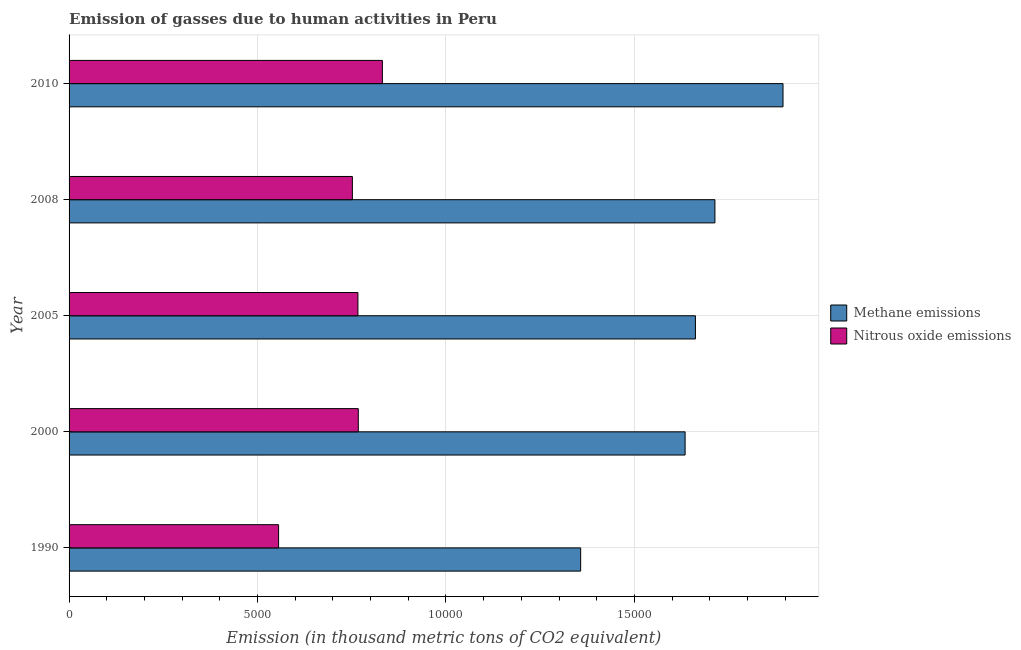How many different coloured bars are there?
Keep it short and to the point. 2. How many groups of bars are there?
Keep it short and to the point. 5. Are the number of bars on each tick of the Y-axis equal?
Give a very brief answer. Yes. How many bars are there on the 5th tick from the top?
Keep it short and to the point. 2. How many bars are there on the 1st tick from the bottom?
Keep it short and to the point. 2. What is the amount of nitrous oxide emissions in 1990?
Keep it short and to the point. 5559.3. Across all years, what is the maximum amount of methane emissions?
Your answer should be very brief. 1.89e+04. Across all years, what is the minimum amount of nitrous oxide emissions?
Your response must be concise. 5559.3. In which year was the amount of nitrous oxide emissions maximum?
Ensure brevity in your answer.  2010. What is the total amount of methane emissions in the graph?
Provide a short and direct response. 8.26e+04. What is the difference between the amount of methane emissions in 1990 and that in 2008?
Provide a short and direct response. -3562.7. What is the difference between the amount of methane emissions in 2000 and the amount of nitrous oxide emissions in 1990?
Provide a succinct answer. 1.08e+04. What is the average amount of nitrous oxide emissions per year?
Provide a succinct answer. 7345.44. In the year 2000, what is the difference between the amount of nitrous oxide emissions and amount of methane emissions?
Give a very brief answer. -8671.2. What is the difference between the highest and the second highest amount of nitrous oxide emissions?
Provide a succinct answer. 639.1. What is the difference between the highest and the lowest amount of nitrous oxide emissions?
Provide a succinct answer. 2753.7. What does the 1st bar from the top in 2000 represents?
Ensure brevity in your answer.  Nitrous oxide emissions. What does the 2nd bar from the bottom in 2010 represents?
Keep it short and to the point. Nitrous oxide emissions. How many bars are there?
Keep it short and to the point. 10. Are all the bars in the graph horizontal?
Offer a very short reply. Yes. How many years are there in the graph?
Provide a short and direct response. 5. Does the graph contain any zero values?
Your answer should be very brief. No. Does the graph contain grids?
Your response must be concise. Yes. How many legend labels are there?
Offer a very short reply. 2. How are the legend labels stacked?
Provide a succinct answer. Vertical. What is the title of the graph?
Give a very brief answer. Emission of gasses due to human activities in Peru. What is the label or title of the X-axis?
Make the answer very short. Emission (in thousand metric tons of CO2 equivalent). What is the label or title of the Y-axis?
Offer a very short reply. Year. What is the Emission (in thousand metric tons of CO2 equivalent) in Methane emissions in 1990?
Your answer should be compact. 1.36e+04. What is the Emission (in thousand metric tons of CO2 equivalent) of Nitrous oxide emissions in 1990?
Keep it short and to the point. 5559.3. What is the Emission (in thousand metric tons of CO2 equivalent) in Methane emissions in 2000?
Give a very brief answer. 1.63e+04. What is the Emission (in thousand metric tons of CO2 equivalent) in Nitrous oxide emissions in 2000?
Your answer should be very brief. 7673.9. What is the Emission (in thousand metric tons of CO2 equivalent) of Methane emissions in 2005?
Ensure brevity in your answer.  1.66e+04. What is the Emission (in thousand metric tons of CO2 equivalent) in Nitrous oxide emissions in 2005?
Offer a terse response. 7664.2. What is the Emission (in thousand metric tons of CO2 equivalent) in Methane emissions in 2008?
Keep it short and to the point. 1.71e+04. What is the Emission (in thousand metric tons of CO2 equivalent) in Nitrous oxide emissions in 2008?
Offer a terse response. 7516.8. What is the Emission (in thousand metric tons of CO2 equivalent) of Methane emissions in 2010?
Your answer should be very brief. 1.89e+04. What is the Emission (in thousand metric tons of CO2 equivalent) in Nitrous oxide emissions in 2010?
Ensure brevity in your answer.  8313. Across all years, what is the maximum Emission (in thousand metric tons of CO2 equivalent) in Methane emissions?
Ensure brevity in your answer.  1.89e+04. Across all years, what is the maximum Emission (in thousand metric tons of CO2 equivalent) in Nitrous oxide emissions?
Offer a terse response. 8313. Across all years, what is the minimum Emission (in thousand metric tons of CO2 equivalent) in Methane emissions?
Your answer should be compact. 1.36e+04. Across all years, what is the minimum Emission (in thousand metric tons of CO2 equivalent) in Nitrous oxide emissions?
Offer a terse response. 5559.3. What is the total Emission (in thousand metric tons of CO2 equivalent) of Methane emissions in the graph?
Your answer should be very brief. 8.26e+04. What is the total Emission (in thousand metric tons of CO2 equivalent) of Nitrous oxide emissions in the graph?
Offer a terse response. 3.67e+04. What is the difference between the Emission (in thousand metric tons of CO2 equivalent) in Methane emissions in 1990 and that in 2000?
Offer a very short reply. -2771.4. What is the difference between the Emission (in thousand metric tons of CO2 equivalent) of Nitrous oxide emissions in 1990 and that in 2000?
Keep it short and to the point. -2114.6. What is the difference between the Emission (in thousand metric tons of CO2 equivalent) of Methane emissions in 1990 and that in 2005?
Provide a short and direct response. -3045.3. What is the difference between the Emission (in thousand metric tons of CO2 equivalent) in Nitrous oxide emissions in 1990 and that in 2005?
Provide a succinct answer. -2104.9. What is the difference between the Emission (in thousand metric tons of CO2 equivalent) of Methane emissions in 1990 and that in 2008?
Keep it short and to the point. -3562.7. What is the difference between the Emission (in thousand metric tons of CO2 equivalent) of Nitrous oxide emissions in 1990 and that in 2008?
Keep it short and to the point. -1957.5. What is the difference between the Emission (in thousand metric tons of CO2 equivalent) of Methane emissions in 1990 and that in 2010?
Provide a short and direct response. -5369.2. What is the difference between the Emission (in thousand metric tons of CO2 equivalent) of Nitrous oxide emissions in 1990 and that in 2010?
Provide a short and direct response. -2753.7. What is the difference between the Emission (in thousand metric tons of CO2 equivalent) of Methane emissions in 2000 and that in 2005?
Your answer should be compact. -273.9. What is the difference between the Emission (in thousand metric tons of CO2 equivalent) of Methane emissions in 2000 and that in 2008?
Offer a terse response. -791.3. What is the difference between the Emission (in thousand metric tons of CO2 equivalent) in Nitrous oxide emissions in 2000 and that in 2008?
Offer a very short reply. 157.1. What is the difference between the Emission (in thousand metric tons of CO2 equivalent) in Methane emissions in 2000 and that in 2010?
Make the answer very short. -2597.8. What is the difference between the Emission (in thousand metric tons of CO2 equivalent) of Nitrous oxide emissions in 2000 and that in 2010?
Keep it short and to the point. -639.1. What is the difference between the Emission (in thousand metric tons of CO2 equivalent) of Methane emissions in 2005 and that in 2008?
Keep it short and to the point. -517.4. What is the difference between the Emission (in thousand metric tons of CO2 equivalent) in Nitrous oxide emissions in 2005 and that in 2008?
Offer a terse response. 147.4. What is the difference between the Emission (in thousand metric tons of CO2 equivalent) of Methane emissions in 2005 and that in 2010?
Ensure brevity in your answer.  -2323.9. What is the difference between the Emission (in thousand metric tons of CO2 equivalent) of Nitrous oxide emissions in 2005 and that in 2010?
Give a very brief answer. -648.8. What is the difference between the Emission (in thousand metric tons of CO2 equivalent) of Methane emissions in 2008 and that in 2010?
Keep it short and to the point. -1806.5. What is the difference between the Emission (in thousand metric tons of CO2 equivalent) in Nitrous oxide emissions in 2008 and that in 2010?
Provide a short and direct response. -796.2. What is the difference between the Emission (in thousand metric tons of CO2 equivalent) in Methane emissions in 1990 and the Emission (in thousand metric tons of CO2 equivalent) in Nitrous oxide emissions in 2000?
Keep it short and to the point. 5899.8. What is the difference between the Emission (in thousand metric tons of CO2 equivalent) in Methane emissions in 1990 and the Emission (in thousand metric tons of CO2 equivalent) in Nitrous oxide emissions in 2005?
Your response must be concise. 5909.5. What is the difference between the Emission (in thousand metric tons of CO2 equivalent) of Methane emissions in 1990 and the Emission (in thousand metric tons of CO2 equivalent) of Nitrous oxide emissions in 2008?
Offer a terse response. 6056.9. What is the difference between the Emission (in thousand metric tons of CO2 equivalent) in Methane emissions in 1990 and the Emission (in thousand metric tons of CO2 equivalent) in Nitrous oxide emissions in 2010?
Give a very brief answer. 5260.7. What is the difference between the Emission (in thousand metric tons of CO2 equivalent) of Methane emissions in 2000 and the Emission (in thousand metric tons of CO2 equivalent) of Nitrous oxide emissions in 2005?
Provide a short and direct response. 8680.9. What is the difference between the Emission (in thousand metric tons of CO2 equivalent) in Methane emissions in 2000 and the Emission (in thousand metric tons of CO2 equivalent) in Nitrous oxide emissions in 2008?
Offer a very short reply. 8828.3. What is the difference between the Emission (in thousand metric tons of CO2 equivalent) in Methane emissions in 2000 and the Emission (in thousand metric tons of CO2 equivalent) in Nitrous oxide emissions in 2010?
Give a very brief answer. 8032.1. What is the difference between the Emission (in thousand metric tons of CO2 equivalent) of Methane emissions in 2005 and the Emission (in thousand metric tons of CO2 equivalent) of Nitrous oxide emissions in 2008?
Make the answer very short. 9102.2. What is the difference between the Emission (in thousand metric tons of CO2 equivalent) of Methane emissions in 2005 and the Emission (in thousand metric tons of CO2 equivalent) of Nitrous oxide emissions in 2010?
Give a very brief answer. 8306. What is the difference between the Emission (in thousand metric tons of CO2 equivalent) of Methane emissions in 2008 and the Emission (in thousand metric tons of CO2 equivalent) of Nitrous oxide emissions in 2010?
Ensure brevity in your answer.  8823.4. What is the average Emission (in thousand metric tons of CO2 equivalent) in Methane emissions per year?
Keep it short and to the point. 1.65e+04. What is the average Emission (in thousand metric tons of CO2 equivalent) in Nitrous oxide emissions per year?
Offer a terse response. 7345.44. In the year 1990, what is the difference between the Emission (in thousand metric tons of CO2 equivalent) in Methane emissions and Emission (in thousand metric tons of CO2 equivalent) in Nitrous oxide emissions?
Your answer should be compact. 8014.4. In the year 2000, what is the difference between the Emission (in thousand metric tons of CO2 equivalent) of Methane emissions and Emission (in thousand metric tons of CO2 equivalent) of Nitrous oxide emissions?
Offer a very short reply. 8671.2. In the year 2005, what is the difference between the Emission (in thousand metric tons of CO2 equivalent) of Methane emissions and Emission (in thousand metric tons of CO2 equivalent) of Nitrous oxide emissions?
Ensure brevity in your answer.  8954.8. In the year 2008, what is the difference between the Emission (in thousand metric tons of CO2 equivalent) of Methane emissions and Emission (in thousand metric tons of CO2 equivalent) of Nitrous oxide emissions?
Your answer should be compact. 9619.6. In the year 2010, what is the difference between the Emission (in thousand metric tons of CO2 equivalent) of Methane emissions and Emission (in thousand metric tons of CO2 equivalent) of Nitrous oxide emissions?
Provide a short and direct response. 1.06e+04. What is the ratio of the Emission (in thousand metric tons of CO2 equivalent) of Methane emissions in 1990 to that in 2000?
Your answer should be compact. 0.83. What is the ratio of the Emission (in thousand metric tons of CO2 equivalent) in Nitrous oxide emissions in 1990 to that in 2000?
Give a very brief answer. 0.72. What is the ratio of the Emission (in thousand metric tons of CO2 equivalent) in Methane emissions in 1990 to that in 2005?
Offer a terse response. 0.82. What is the ratio of the Emission (in thousand metric tons of CO2 equivalent) in Nitrous oxide emissions in 1990 to that in 2005?
Provide a short and direct response. 0.73. What is the ratio of the Emission (in thousand metric tons of CO2 equivalent) in Methane emissions in 1990 to that in 2008?
Offer a terse response. 0.79. What is the ratio of the Emission (in thousand metric tons of CO2 equivalent) in Nitrous oxide emissions in 1990 to that in 2008?
Your answer should be very brief. 0.74. What is the ratio of the Emission (in thousand metric tons of CO2 equivalent) in Methane emissions in 1990 to that in 2010?
Provide a short and direct response. 0.72. What is the ratio of the Emission (in thousand metric tons of CO2 equivalent) of Nitrous oxide emissions in 1990 to that in 2010?
Provide a succinct answer. 0.67. What is the ratio of the Emission (in thousand metric tons of CO2 equivalent) of Methane emissions in 2000 to that in 2005?
Your response must be concise. 0.98. What is the ratio of the Emission (in thousand metric tons of CO2 equivalent) in Methane emissions in 2000 to that in 2008?
Make the answer very short. 0.95. What is the ratio of the Emission (in thousand metric tons of CO2 equivalent) in Nitrous oxide emissions in 2000 to that in 2008?
Ensure brevity in your answer.  1.02. What is the ratio of the Emission (in thousand metric tons of CO2 equivalent) in Methane emissions in 2000 to that in 2010?
Offer a terse response. 0.86. What is the ratio of the Emission (in thousand metric tons of CO2 equivalent) of Methane emissions in 2005 to that in 2008?
Your answer should be very brief. 0.97. What is the ratio of the Emission (in thousand metric tons of CO2 equivalent) in Nitrous oxide emissions in 2005 to that in 2008?
Give a very brief answer. 1.02. What is the ratio of the Emission (in thousand metric tons of CO2 equivalent) of Methane emissions in 2005 to that in 2010?
Your answer should be compact. 0.88. What is the ratio of the Emission (in thousand metric tons of CO2 equivalent) in Nitrous oxide emissions in 2005 to that in 2010?
Ensure brevity in your answer.  0.92. What is the ratio of the Emission (in thousand metric tons of CO2 equivalent) in Methane emissions in 2008 to that in 2010?
Your answer should be very brief. 0.9. What is the ratio of the Emission (in thousand metric tons of CO2 equivalent) in Nitrous oxide emissions in 2008 to that in 2010?
Your answer should be compact. 0.9. What is the difference between the highest and the second highest Emission (in thousand metric tons of CO2 equivalent) in Methane emissions?
Provide a succinct answer. 1806.5. What is the difference between the highest and the second highest Emission (in thousand metric tons of CO2 equivalent) of Nitrous oxide emissions?
Keep it short and to the point. 639.1. What is the difference between the highest and the lowest Emission (in thousand metric tons of CO2 equivalent) of Methane emissions?
Offer a terse response. 5369.2. What is the difference between the highest and the lowest Emission (in thousand metric tons of CO2 equivalent) in Nitrous oxide emissions?
Keep it short and to the point. 2753.7. 